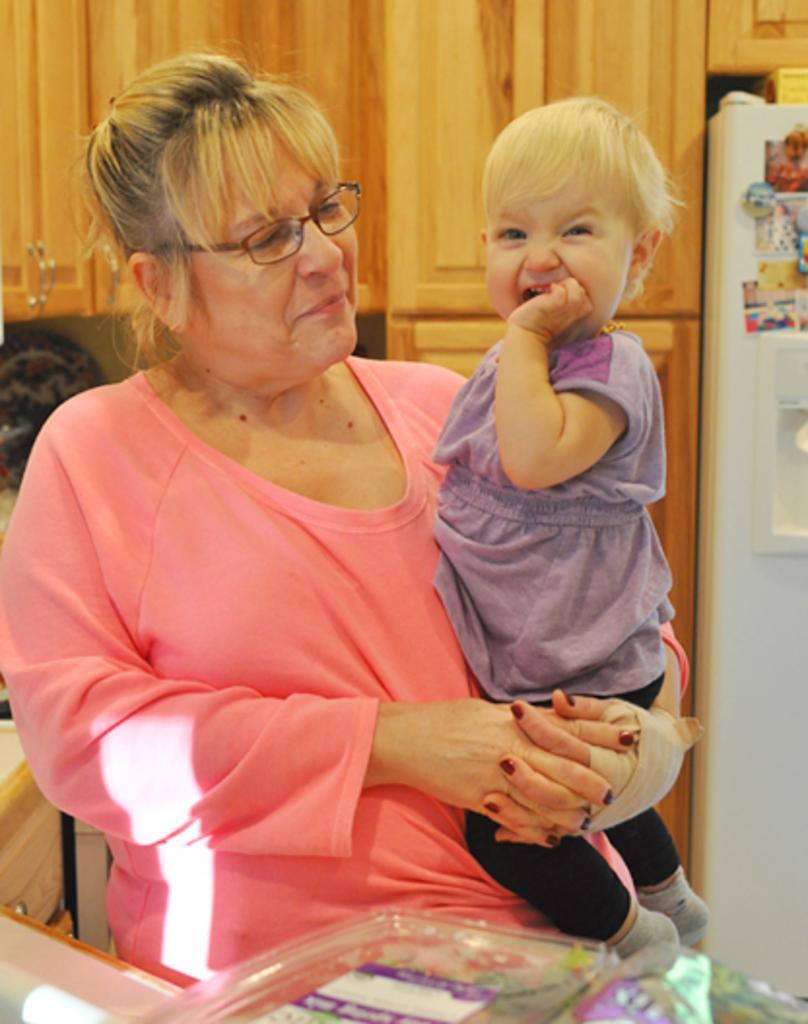How would you summarize this image in a sentence or two? In this image we can see a woman carrying a baby. The woman wore spectacles. In the background we can see cupboards and fridge. 